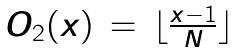<formula> <loc_0><loc_0><loc_500><loc_500>\begin{matrix} O _ { 2 } ( x ) & = & \lfloor \frac { x - 1 } { N } \rfloor \end{matrix}</formula> 